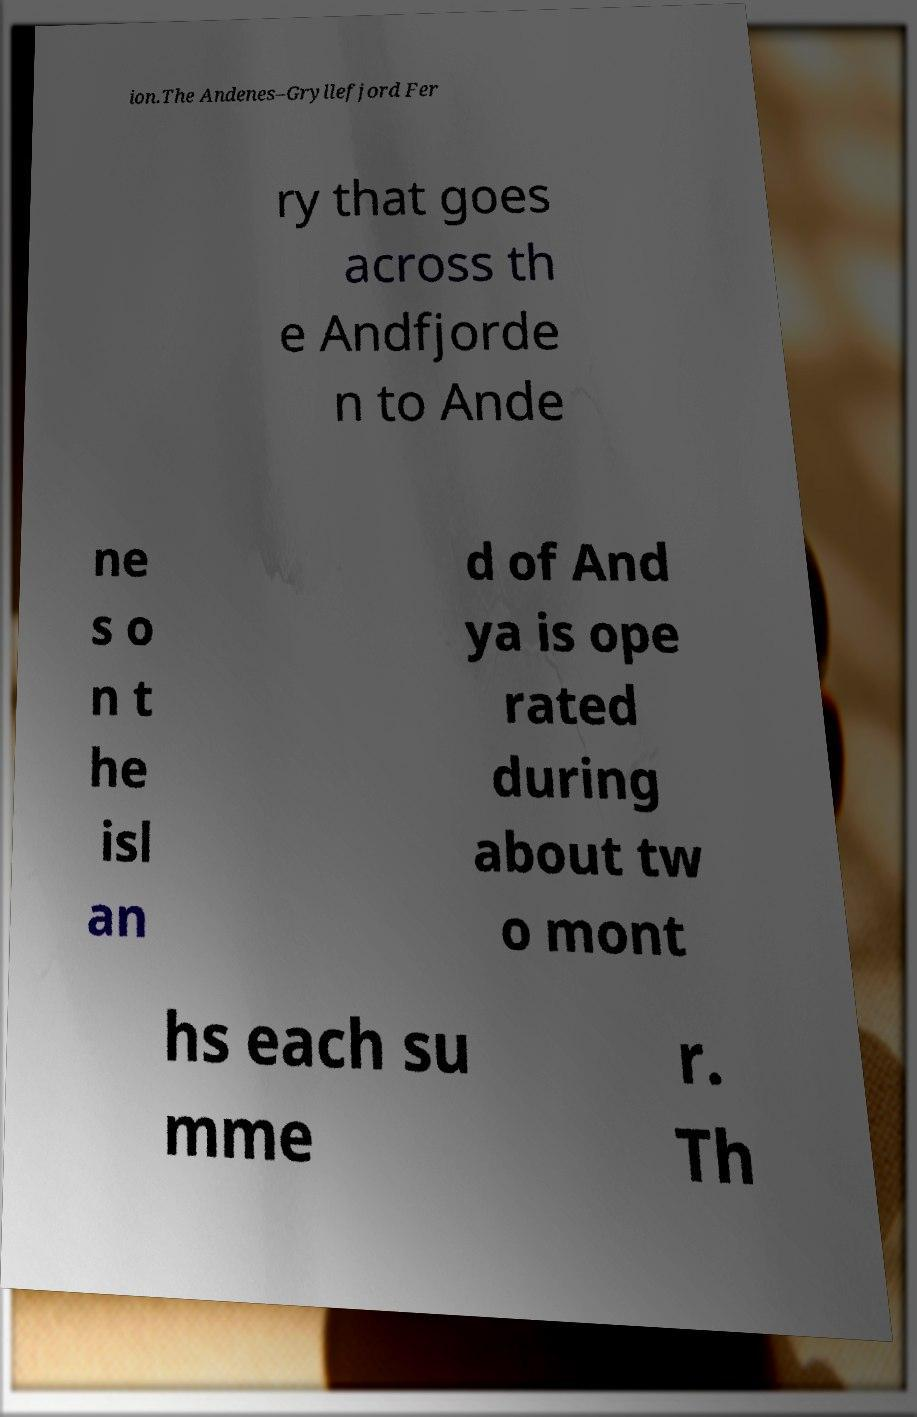Can you read and provide the text displayed in the image?This photo seems to have some interesting text. Can you extract and type it out for me? ion.The Andenes–Gryllefjord Fer ry that goes across th e Andfjorde n to Ande ne s o n t he isl an d of And ya is ope rated during about tw o mont hs each su mme r. Th 